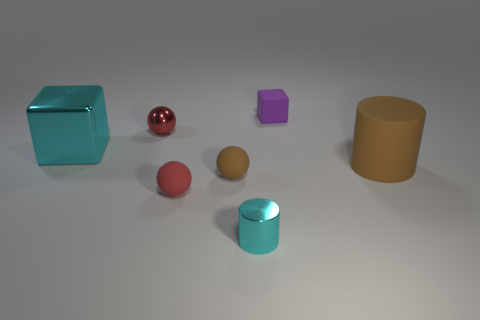Add 1 small red rubber spheres. How many objects exist? 8 Subtract all spheres. How many objects are left? 4 Add 3 tiny purple cubes. How many tiny purple cubes exist? 4 Subtract 0 purple cylinders. How many objects are left? 7 Subtract all red objects. Subtract all large cyan things. How many objects are left? 4 Add 4 large brown matte cylinders. How many large brown matte cylinders are left? 5 